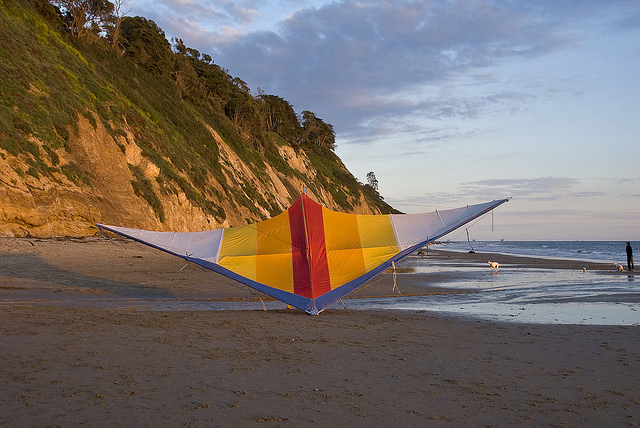What is the location of the kite in relation to the ocean? The colorful kite is positioned on the sandy beach, relatively close to the ocean’s edge. 